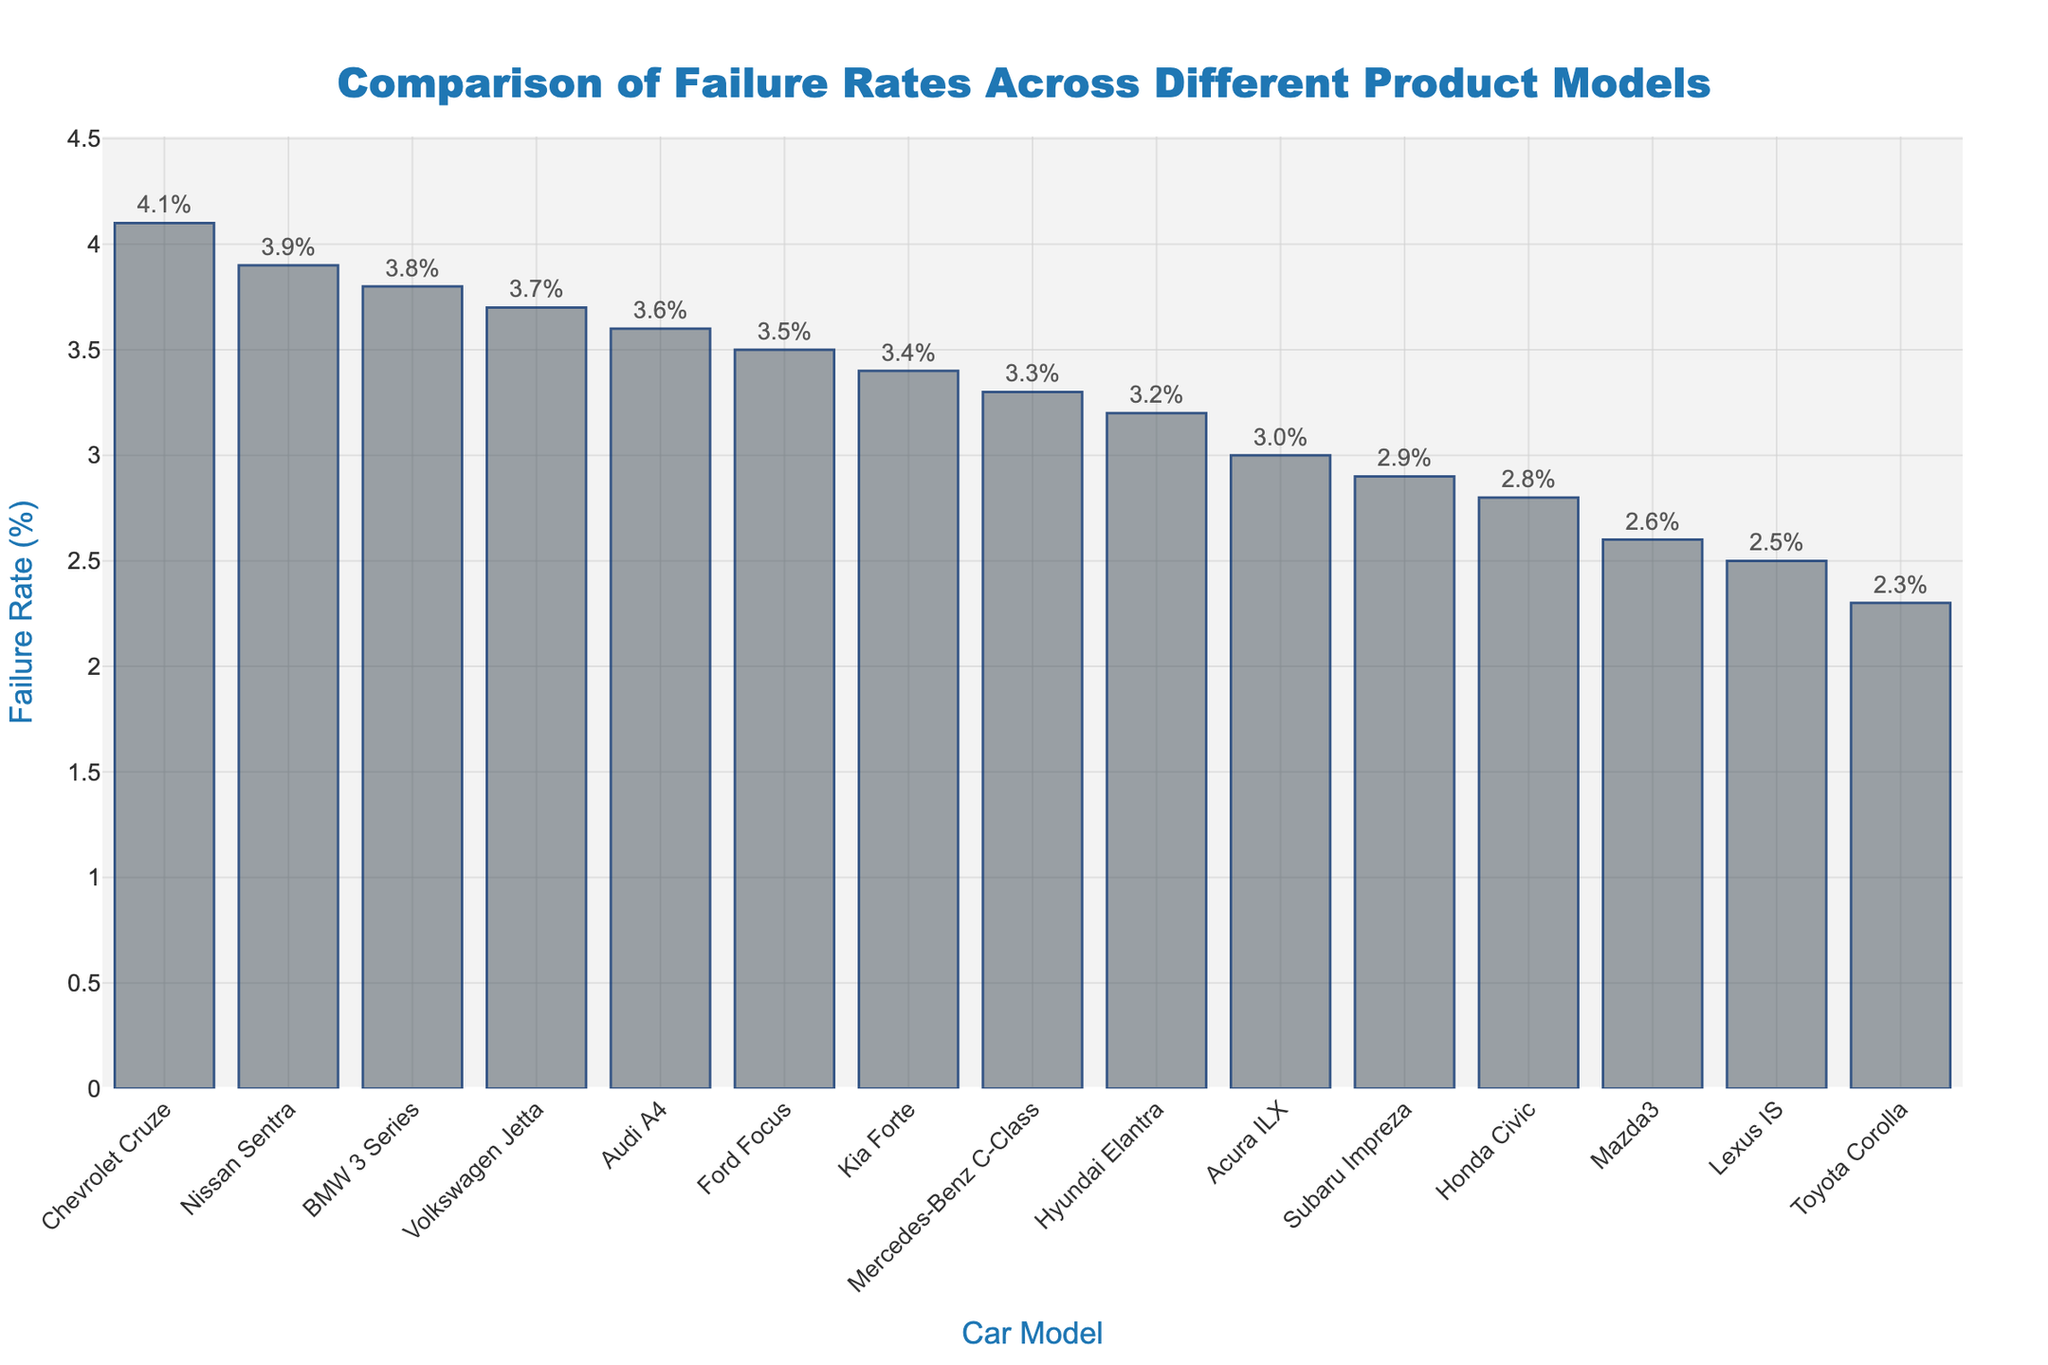Which car model has the highest failure rate? The bar chart shows the heights of bars corresponding to the failure rates of different car models. The tallest bar represents the car model with the highest failure rate.
Answer: Chevrolet Cruze Which car model has the lowest failure rate? The bar chart shows the heights of bars corresponding to the failure rates of different car models. The shortest bar represents the car model with the lowest failure rate.
Answer: Toyota Corolla How much higher is the failure rate of Chevrolet Cruze compared to Toyota Corolla? To find the difference, look at the failure rates of both models in the y-axis. Chevrolet Cruze has a rate of 4.1% and Toyota Corolla has 2.3%, so the difference is 4.1% - 2.3% = 1.8%.
Answer: 1.8% Which car models have a failure rate greater than 3.5%? Identify bars that extend above the 3.5% mark on the y-axis. These models are Chevrolet Cruze (4.1%), Nissan Sentra (3.9%), BMW 3 Series (3.8%), and Volkswagen Jetta (3.7%).
Answer: Chevrolet Cruze, Nissan Sentra, BMW 3 Series, Volkswagen Jetta How does the failure rate of Ford Focus compare to Mazda3? Check the heights of the bars representing Ford Focus and Mazda3. Ford Focus has a failure rate of 3.5% while Mazda3 has a rate of 2.6%. Thus, Ford Focus has a higher failure rate by 0.9%.
Answer: Ford Focus is 0.9% higher What is the average failure rate of all car models? Add all failure rates from the data and divide by the number of car models: (2.3% + 2.8% + 3.5% + 4.1% + 3.9% + 3.2% + 3.7% + 2.6% + 2.9% + 3.4% + 3.8% + 3.6% + 3.3% + 2.5% + 3.0%) / 15 ≈ 3.32%.
Answer: 3.32% Which car models have failure rates between 3.0% and 3.5%? Identify bars that reach between the 3.0% and 3.5% marks on the y-axis. These models are Hyundai Elantra (3.2%), Kia Forte (3.4%), Mercedes-Benz C-Class (3.3%), and Acura ILX (3.0%).
Answer: Hyundai Elantra, Kia Forte, Mercedes-Benz C-Class, Acura ILX What is the combined failure rate of the Mazda3, Toyota Corolla, and Lexus IS? Sum the failure rates of these three models: Mazda3 (2.6%), Toyota Corolla (2.3%), Lexus IS (2.5%) = 2.6% + 2.3% + 2.5% = 7.4%
Answer: 7.4% Which car model has a failure rate closest to 3.0%? Check the bars around the 3.0% mark on the y-axis. Acura ILX has a failure rate of exactly 3.0%.
Answer: Acura ILX How does the failure rate of Hyundai Elantra compare to the average failure rate? The average failure rate is 3.32%. Hyundai Elantra has a failure rate of 3.2%. To compare, subtract the two values: 3.2% - 3.32% = -0.12%. Hence, Hyundai Elantra's failure rate is 0.12% lower than the average.
Answer: 0.12% lower 